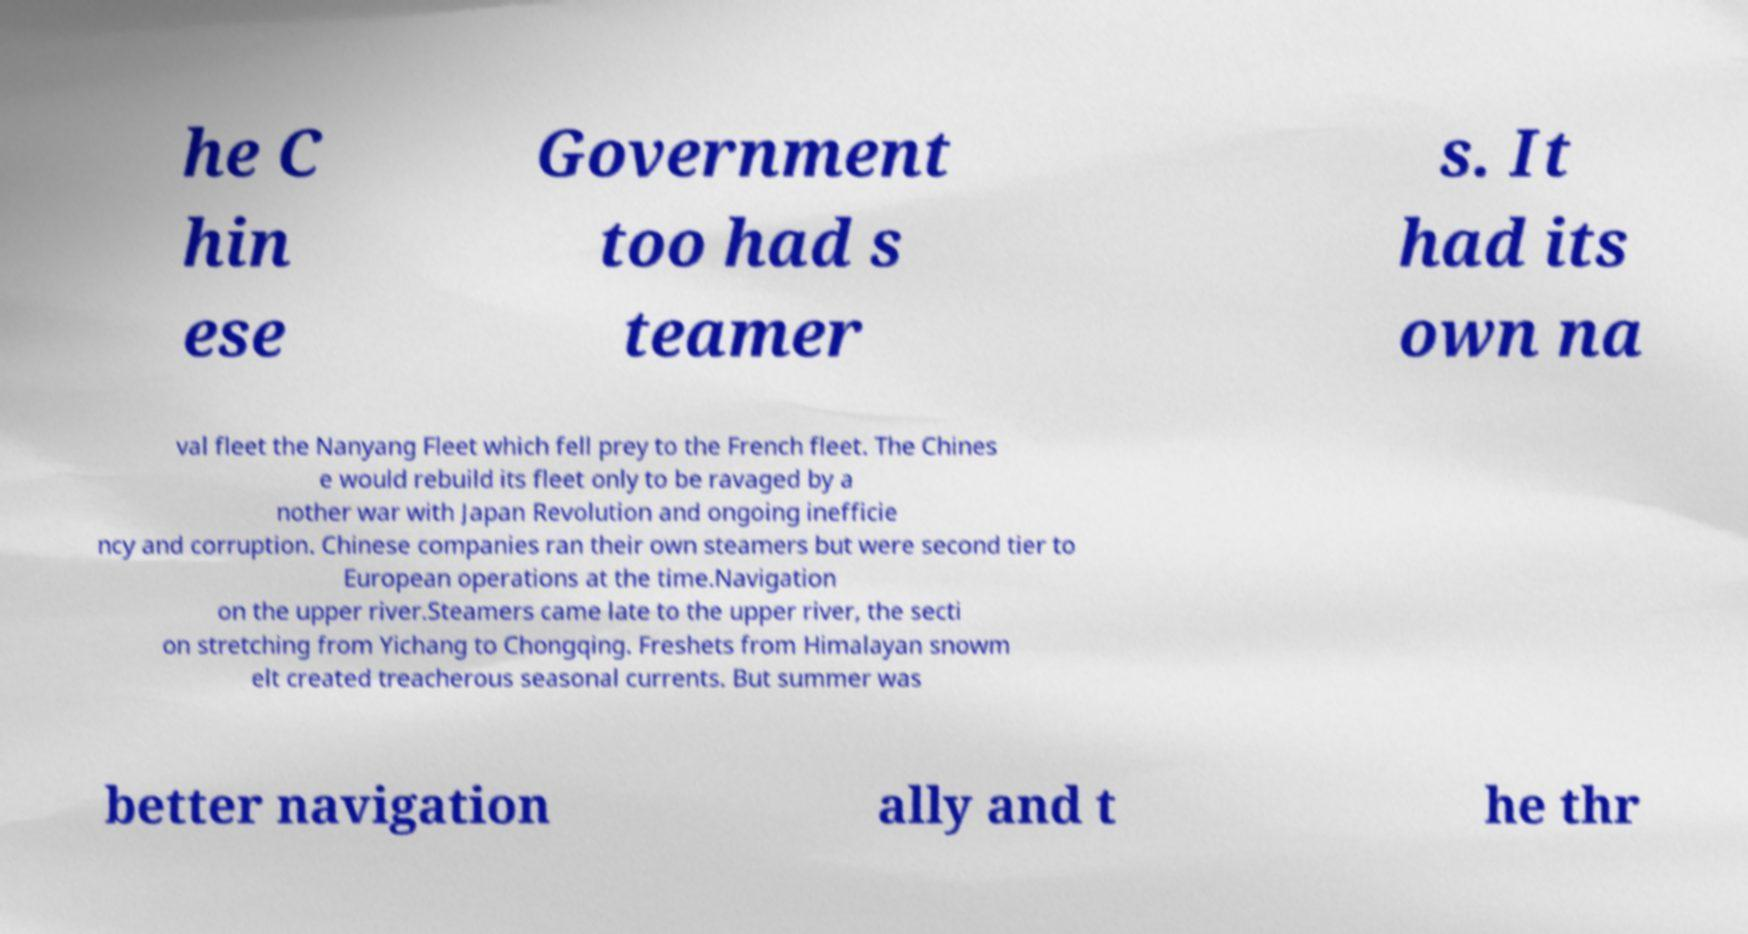Could you assist in decoding the text presented in this image and type it out clearly? he C hin ese Government too had s teamer s. It had its own na val fleet the Nanyang Fleet which fell prey to the French fleet. The Chines e would rebuild its fleet only to be ravaged by a nother war with Japan Revolution and ongoing inefficie ncy and corruption. Chinese companies ran their own steamers but were second tier to European operations at the time.Navigation on the upper river.Steamers came late to the upper river, the secti on stretching from Yichang to Chongqing. Freshets from Himalayan snowm elt created treacherous seasonal currents. But summer was better navigation ally and t he thr 